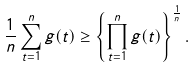Convert formula to latex. <formula><loc_0><loc_0><loc_500><loc_500>\frac { 1 } { n } \sum _ { t = 1 } ^ { n } g ( t ) \geq \left \{ \prod _ { t = 1 } ^ { n } g ( t ) \right \} ^ { \frac { 1 } { n } } .</formula> 